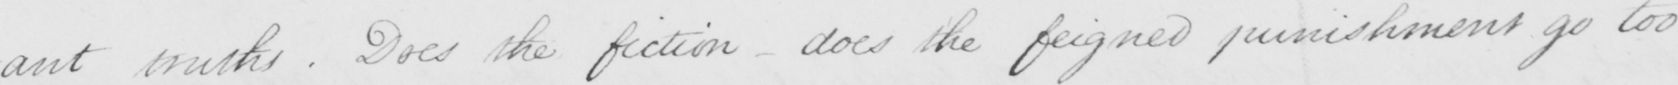What is written in this line of handwriting? truths . Does the fiction  _  does the feigned punishment go too 